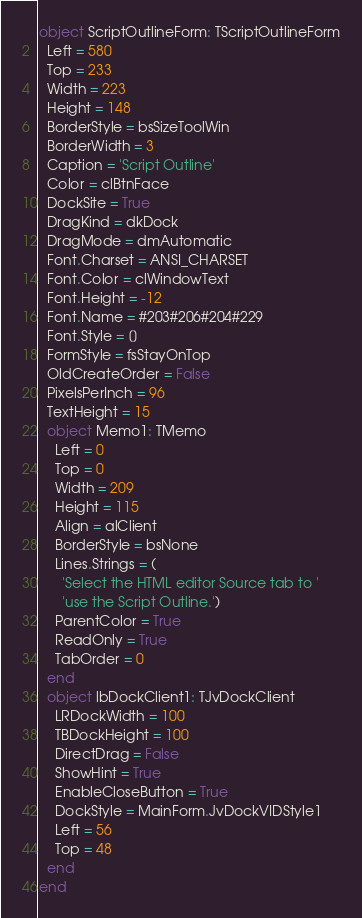Convert code to text. <code><loc_0><loc_0><loc_500><loc_500><_Pascal_>object ScriptOutlineForm: TScriptOutlineForm
  Left = 580
  Top = 233
  Width = 223
  Height = 148
  BorderStyle = bsSizeToolWin
  BorderWidth = 3
  Caption = 'Script Outline'
  Color = clBtnFace
  DockSite = True
  DragKind = dkDock
  DragMode = dmAutomatic
  Font.Charset = ANSI_CHARSET
  Font.Color = clWindowText
  Font.Height = -12
  Font.Name = #203#206#204#229
  Font.Style = []
  FormStyle = fsStayOnTop
  OldCreateOrder = False
  PixelsPerInch = 96
  TextHeight = 15
  object Memo1: TMemo
    Left = 0
    Top = 0
    Width = 209
    Height = 115
    Align = alClient
    BorderStyle = bsNone
    Lines.Strings = (
      'Select the HTML editor Source tab to '
      'use the Script Outline.')
    ParentColor = True
    ReadOnly = True
    TabOrder = 0
  end
  object lbDockClient1: TJvDockClient
    LRDockWidth = 100
    TBDockHeight = 100
    DirectDrag = False
    ShowHint = True
    EnableCloseButton = True
    DockStyle = MainForm.JvDockVIDStyle1
    Left = 56
    Top = 48
  end
end
</code> 